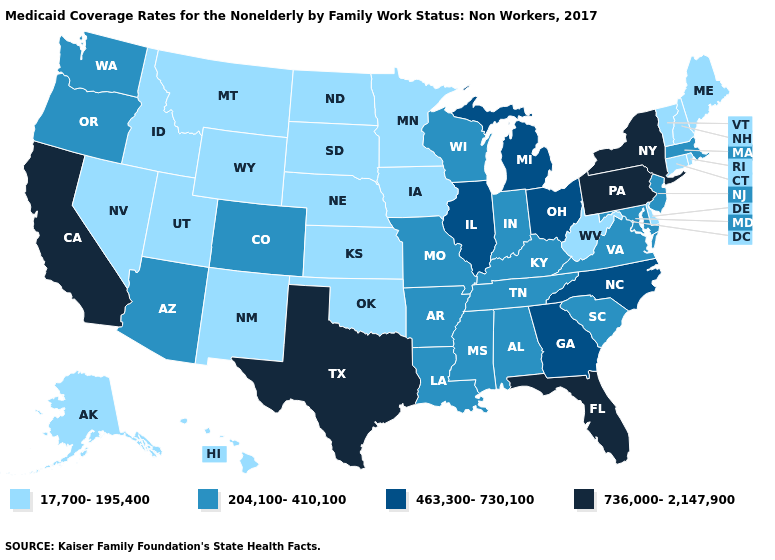What is the highest value in the USA?
Keep it brief. 736,000-2,147,900. What is the value of South Dakota?
Write a very short answer. 17,700-195,400. Which states have the highest value in the USA?
Keep it brief. California, Florida, New York, Pennsylvania, Texas. Name the states that have a value in the range 736,000-2,147,900?
Answer briefly. California, Florida, New York, Pennsylvania, Texas. Name the states that have a value in the range 17,700-195,400?
Concise answer only. Alaska, Connecticut, Delaware, Hawaii, Idaho, Iowa, Kansas, Maine, Minnesota, Montana, Nebraska, Nevada, New Hampshire, New Mexico, North Dakota, Oklahoma, Rhode Island, South Dakota, Utah, Vermont, West Virginia, Wyoming. What is the lowest value in the USA?
Be succinct. 17,700-195,400. Name the states that have a value in the range 736,000-2,147,900?
Write a very short answer. California, Florida, New York, Pennsylvania, Texas. What is the value of Alabama?
Answer briefly. 204,100-410,100. Does Mississippi have a higher value than Vermont?
Keep it brief. Yes. How many symbols are there in the legend?
Answer briefly. 4. Does Delaware have the highest value in the USA?
Keep it brief. No. Does Hawaii have the same value as Michigan?
Keep it brief. No. Name the states that have a value in the range 736,000-2,147,900?
Write a very short answer. California, Florida, New York, Pennsylvania, Texas. What is the highest value in the USA?
Answer briefly. 736,000-2,147,900. Does the first symbol in the legend represent the smallest category?
Give a very brief answer. Yes. 